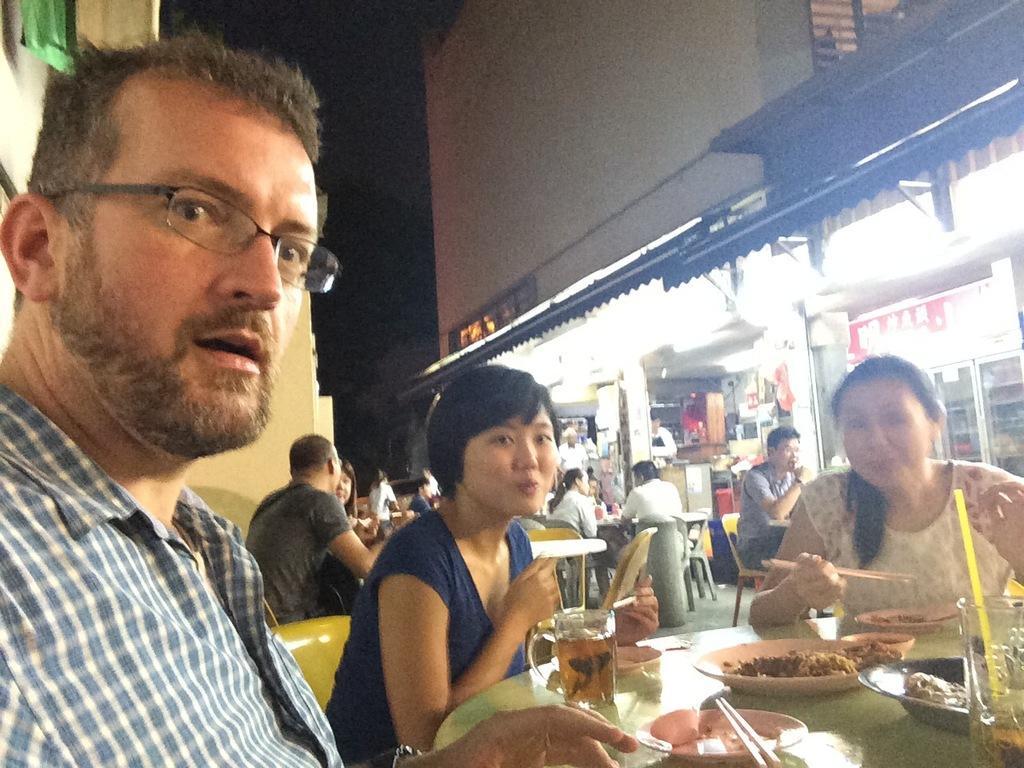In one or two sentences, can you explain what this image depicts? In this image I can see few people are sitting on the chairs. I can see glasses,plates,spoons,food items and few items on the tables. Back I can see stores,lights,banners,building and window. 